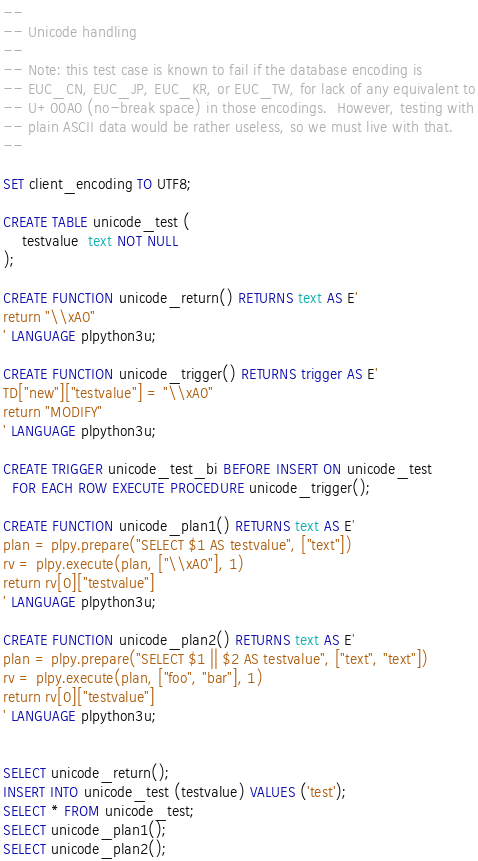<code> <loc_0><loc_0><loc_500><loc_500><_SQL_>--
-- Unicode handling
--
-- Note: this test case is known to fail if the database encoding is
-- EUC_CN, EUC_JP, EUC_KR, or EUC_TW, for lack of any equivalent to
-- U+00A0 (no-break space) in those encodings.  However, testing with
-- plain ASCII data would be rather useless, so we must live with that.
--

SET client_encoding TO UTF8;

CREATE TABLE unicode_test (
	testvalue  text NOT NULL
);

CREATE FUNCTION unicode_return() RETURNS text AS E'
return "\\xA0"
' LANGUAGE plpython3u;

CREATE FUNCTION unicode_trigger() RETURNS trigger AS E'
TD["new"]["testvalue"] = "\\xA0"
return "MODIFY"
' LANGUAGE plpython3u;

CREATE TRIGGER unicode_test_bi BEFORE INSERT ON unicode_test
  FOR EACH ROW EXECUTE PROCEDURE unicode_trigger();

CREATE FUNCTION unicode_plan1() RETURNS text AS E'
plan = plpy.prepare("SELECT $1 AS testvalue", ["text"])
rv = plpy.execute(plan, ["\\xA0"], 1)
return rv[0]["testvalue"]
' LANGUAGE plpython3u;

CREATE FUNCTION unicode_plan2() RETURNS text AS E'
plan = plpy.prepare("SELECT $1 || $2 AS testvalue", ["text", "text"])
rv = plpy.execute(plan, ["foo", "bar"], 1)
return rv[0]["testvalue"]
' LANGUAGE plpython3u;


SELECT unicode_return();
INSERT INTO unicode_test (testvalue) VALUES ('test');
SELECT * FROM unicode_test;
SELECT unicode_plan1();
SELECT unicode_plan2();
</code> 